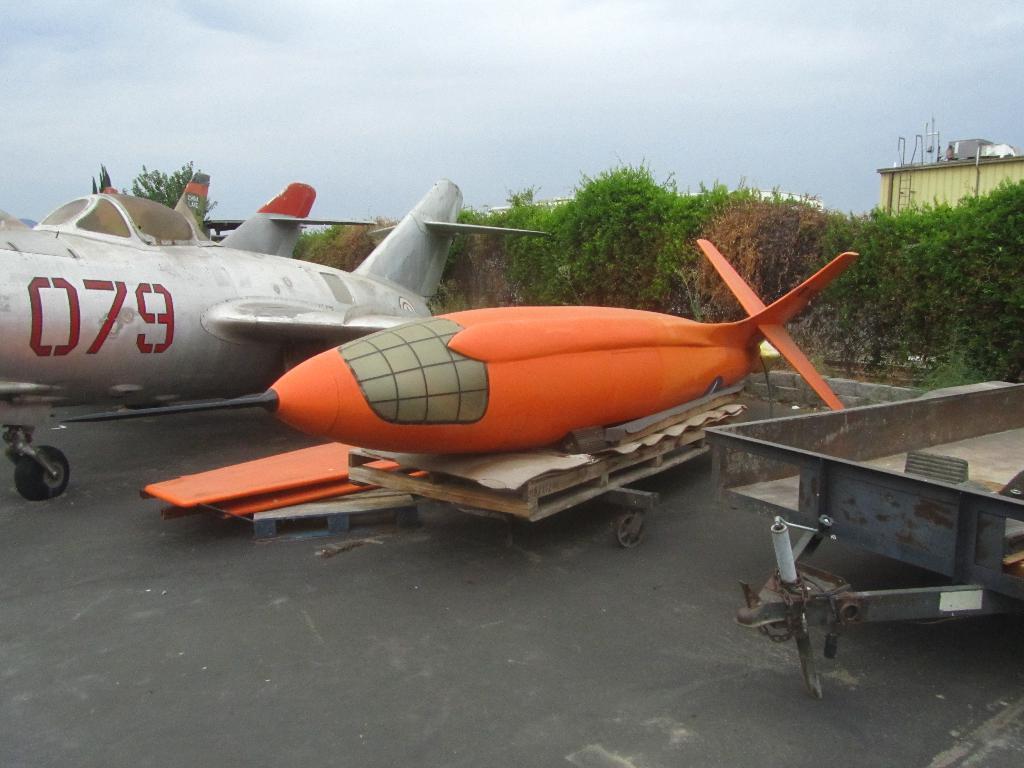What number is the silver plane?
Ensure brevity in your answer.  079. What is the silver planes id number?
Your response must be concise. 079. 